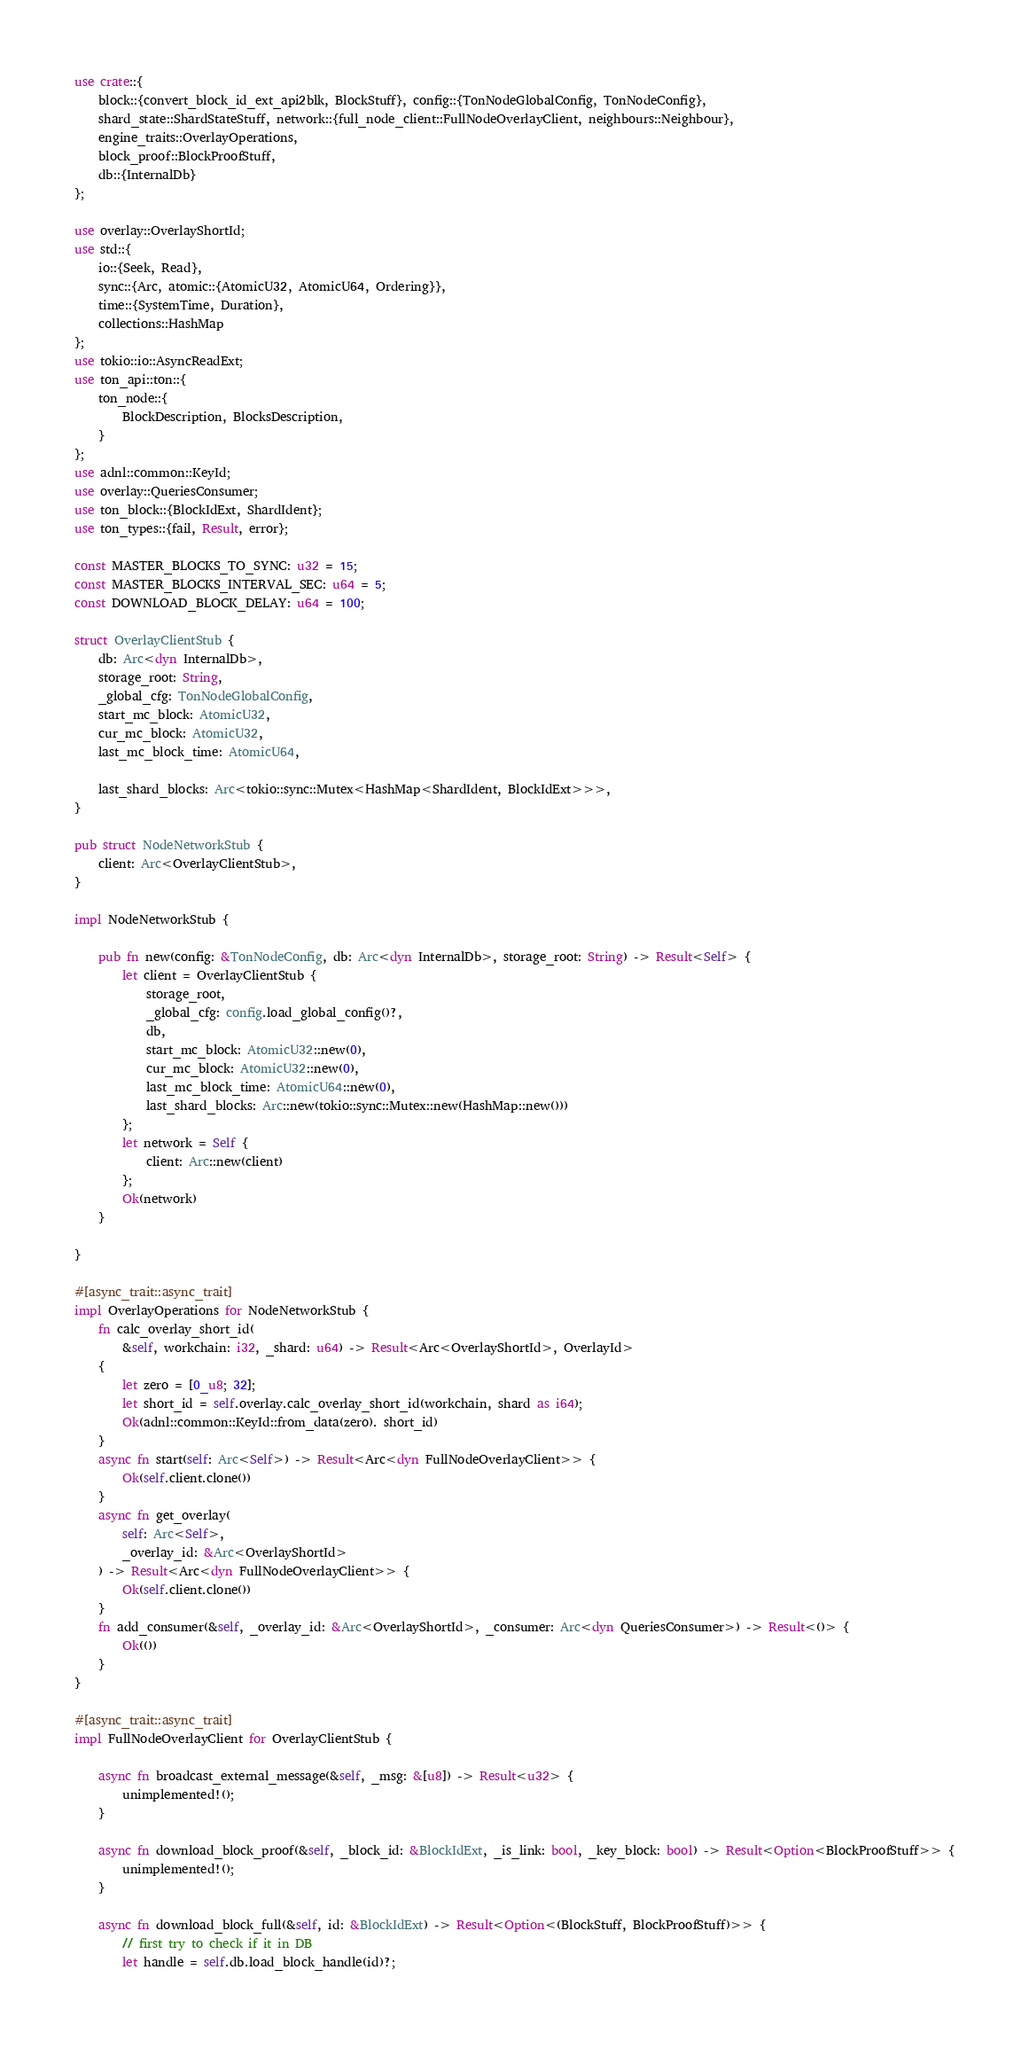Convert code to text. <code><loc_0><loc_0><loc_500><loc_500><_Rust_>use crate::{
    block::{convert_block_id_ext_api2blk, BlockStuff}, config::{TonNodeGlobalConfig, TonNodeConfig},
    shard_state::ShardStateStuff, network::{full_node_client::FullNodeOverlayClient, neighbours::Neighbour},
    engine_traits::OverlayOperations,
    block_proof::BlockProofStuff,
    db::{InternalDb}
};

use overlay::OverlayShortId;
use std::{
    io::{Seek, Read},
    sync::{Arc, atomic::{AtomicU32, AtomicU64, Ordering}},
    time::{SystemTime, Duration},
    collections::HashMap
};
use tokio::io::AsyncReadExt;
use ton_api::ton::{
    ton_node::{ 
        BlockDescription, BlocksDescription,
    }
};
use adnl::common::KeyId;
use overlay::QueriesConsumer;
use ton_block::{BlockIdExt, ShardIdent};
use ton_types::{fail, Result, error};

const MASTER_BLOCKS_TO_SYNC: u32 = 15;
const MASTER_BLOCKS_INTERVAL_SEC: u64 = 5;
const DOWNLOAD_BLOCK_DELAY: u64 = 100;

struct OverlayClientStub {
    db: Arc<dyn InternalDb>,
    storage_root: String,
    _global_cfg: TonNodeGlobalConfig,
    start_mc_block: AtomicU32,
    cur_mc_block: AtomicU32,
    last_mc_block_time: AtomicU64,

    last_shard_blocks: Arc<tokio::sync::Mutex<HashMap<ShardIdent, BlockIdExt>>>,
}

pub struct NodeNetworkStub {
    client: Arc<OverlayClientStub>,
}

impl NodeNetworkStub {

    pub fn new(config: &TonNodeConfig, db: Arc<dyn InternalDb>, storage_root: String) -> Result<Self> {
        let client = OverlayClientStub {
            storage_root,
            _global_cfg: config.load_global_config()?,
            db,
            start_mc_block: AtomicU32::new(0),
            cur_mc_block: AtomicU32::new(0),
            last_mc_block_time: AtomicU64::new(0),
            last_shard_blocks: Arc::new(tokio::sync::Mutex::new(HashMap::new()))
        };
        let network = Self {
            client: Arc::new(client)
        };
        Ok(network)
    }

}

#[async_trait::async_trait]
impl OverlayOperations for NodeNetworkStub {
    fn calc_overlay_short_id(
        &self, workchain: i32, _shard: u64) -> Result<Arc<OverlayShortId>, OverlayId> 
    {
        let zero = [0_u8; 32];
        let short_id = self.overlay.calc_overlay_short_id(workchain, shard as i64);
        Ok(adnl::common::KeyId::from_data(zero). short_id)
    }
    async fn start(self: Arc<Self>) -> Result<Arc<dyn FullNodeOverlayClient>> {
        Ok(self.client.clone())
    }
    async fn get_overlay(
        self: Arc<Self>,
        _overlay_id: &Arc<OverlayShortId>
    ) -> Result<Arc<dyn FullNodeOverlayClient>> {
        Ok(self.client.clone())
    }
    fn add_consumer(&self, _overlay_id: &Arc<OverlayShortId>, _consumer: Arc<dyn QueriesConsumer>) -> Result<()> {
        Ok(())
    }
}

#[async_trait::async_trait]
impl FullNodeOverlayClient for OverlayClientStub {

    async fn broadcast_external_message(&self, _msg: &[u8]) -> Result<u32> {
        unimplemented!();
    }

    async fn download_block_proof(&self, _block_id: &BlockIdExt, _is_link: bool, _key_block: bool) -> Result<Option<BlockProofStuff>> {
        unimplemented!();
    }

    async fn download_block_full(&self, id: &BlockIdExt) -> Result<Option<(BlockStuff, BlockProofStuff)>> {
        // first try to check if it in DB
        let handle = self.db.load_block_handle(id)?;</code> 